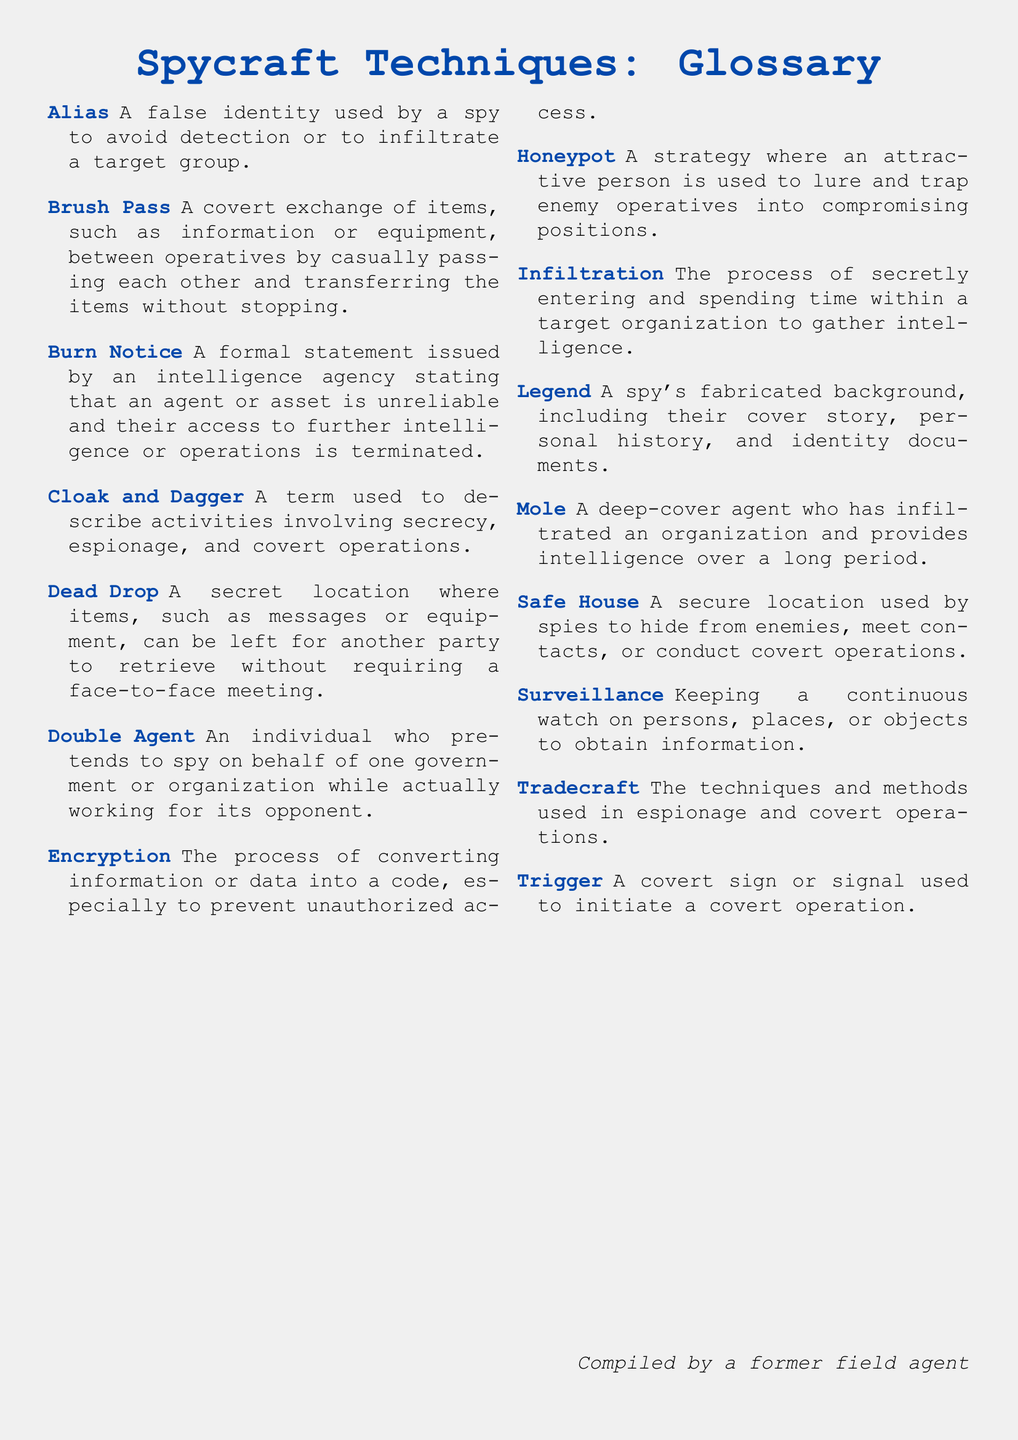What is a false identity used by a spy? An alias is defined in the glossary as a false identity used by a spy to avoid detection or to infiltrate a target group.
Answer: Alias What is a covert exchange of items called? The glossary defines a brush pass as a covert exchange of items, such as information or equipment, between operatives.
Answer: Brush Pass What does a burn notice indicate? A burn notice is a formal statement issued by an intelligence agency indicating that an agent or asset is unreliable.
Answer: Unreliable What is the process of secretly entering a target organization? Infiltration is defined in the glossary as the process of secretly entering and spending time within a target organization.
Answer: Infiltration What term describes a fabricated background for a spy? The glossary describes a legend as a spy's fabricated background, including their cover story and personal history.
Answer: Legend What is a secure location used by spies? A safe house is defined in the glossary as a secure location used by spies to hide from enemies or conduct operations.
Answer: Safe House What technique involves the use of attractive persons to trap enemies? The glossary defines a honeypot as a strategy where an attractive person is used to lure and trap enemy operatives.
Answer: Honeypot What is the term for techniques used in espionage? The glossary states that tradecraft refers to the techniques and methods used in espionage and covert operations.
Answer: Tradecraft What type of agent pretends to work for one government while actually working for another? According to the glossary, a double agent pretends to spy on one government while working for its opponent.
Answer: Double Agent 